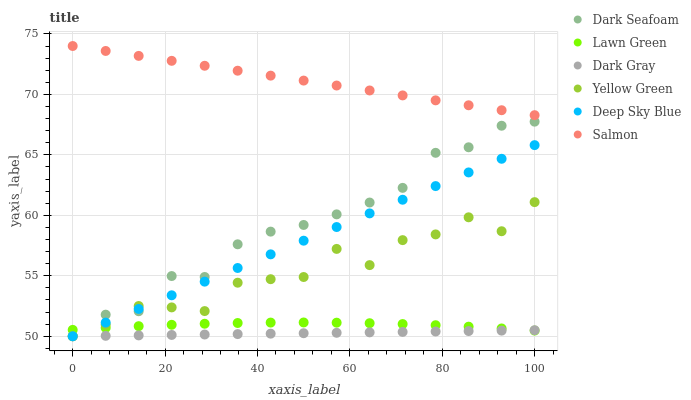Does Dark Gray have the minimum area under the curve?
Answer yes or no. Yes. Does Salmon have the maximum area under the curve?
Answer yes or no. Yes. Does Yellow Green have the minimum area under the curve?
Answer yes or no. No. Does Yellow Green have the maximum area under the curve?
Answer yes or no. No. Is Dark Gray the smoothest?
Answer yes or no. Yes. Is Yellow Green the roughest?
Answer yes or no. Yes. Is Salmon the smoothest?
Answer yes or no. No. Is Salmon the roughest?
Answer yes or no. No. Does Yellow Green have the lowest value?
Answer yes or no. Yes. Does Salmon have the lowest value?
Answer yes or no. No. Does Salmon have the highest value?
Answer yes or no. Yes. Does Yellow Green have the highest value?
Answer yes or no. No. Is Yellow Green less than Salmon?
Answer yes or no. Yes. Is Salmon greater than Lawn Green?
Answer yes or no. Yes. Does Lawn Green intersect Deep Sky Blue?
Answer yes or no. Yes. Is Lawn Green less than Deep Sky Blue?
Answer yes or no. No. Is Lawn Green greater than Deep Sky Blue?
Answer yes or no. No. Does Yellow Green intersect Salmon?
Answer yes or no. No. 